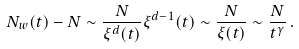Convert formula to latex. <formula><loc_0><loc_0><loc_500><loc_500>N _ { w } ( t ) - N \sim \frac { N } { \xi ^ { d } ( t ) } \xi ^ { d - 1 } ( t ) \sim \frac { N } { \xi ( t ) } \sim \frac { N } { t ^ { \gamma } } \, .</formula> 